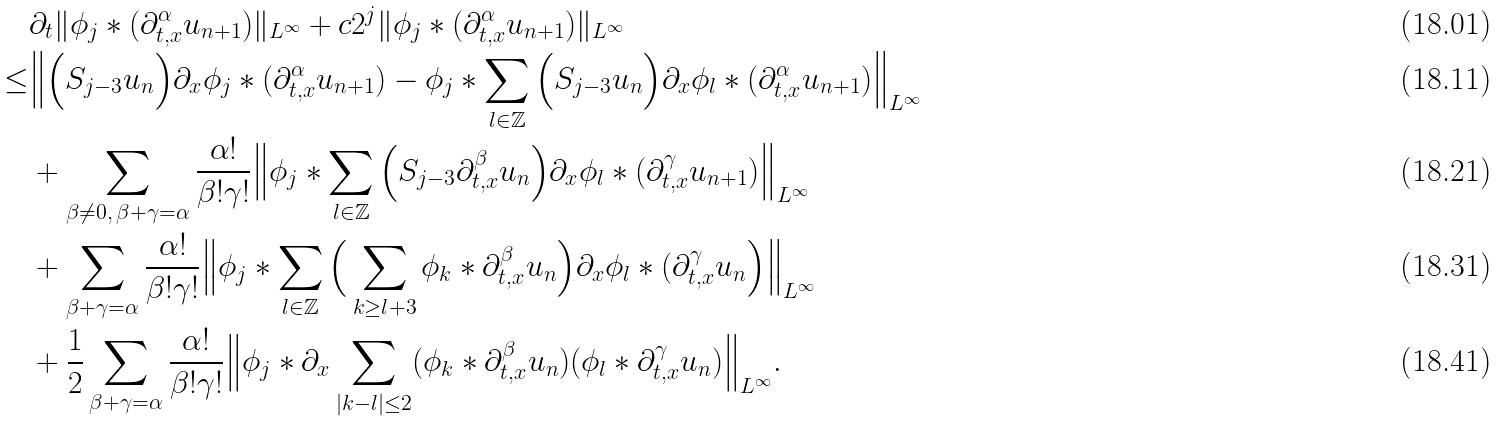<formula> <loc_0><loc_0><loc_500><loc_500>& \partial _ { t } \| \phi _ { j } * ( \partial _ { t , x } ^ { \alpha } u _ { n + 1 } ) \| _ { L ^ { \infty } } + c 2 ^ { j } \| \phi _ { j } * ( \partial _ { t , x } ^ { \alpha } u _ { n + 1 } ) \| _ { L ^ { \infty } } \\ \leq & \Big \| \Big ( S _ { j - 3 } u _ { n } \Big ) \partial _ { x } \phi _ { j } * ( \partial _ { t , x } ^ { \alpha } u _ { n + 1 } ) - \phi _ { j } * \sum _ { l \in \mathbb { Z } } \Big ( S _ { j - 3 } u _ { n } \Big ) \partial _ { x } \phi _ { l } * ( \partial _ { t , x } ^ { \alpha } u _ { n + 1 } ) \Big \| _ { L ^ { \infty } } \\ & + \sum _ { \beta \not = 0 , \, \beta + \gamma = \alpha } \frac { \alpha ! } { \beta ! \gamma ! } \Big \| \phi _ { j } * \sum _ { l \in \mathbb { Z } } \Big ( S _ { j - 3 } \partial _ { t , x } ^ { \beta } u _ { n } \Big ) \partial _ { x } \phi _ { l } * ( \partial _ { t , x } ^ { \gamma } u _ { n + 1 } ) \Big \| _ { L ^ { \infty } } \\ & + \sum _ { \beta + \gamma = \alpha } \frac { \alpha ! } { \beta ! \gamma ! } \Big \| \phi _ { j } * \sum _ { l \in \mathbb { Z } } \Big ( \sum _ { k \geq l + 3 } \phi _ { k } * \partial _ { t , x } ^ { \beta } u _ { n } \Big ) \partial _ { x } \phi _ { l } * ( \partial _ { t , x } ^ { \gamma } u _ { n } \Big ) \Big \| _ { L ^ { \infty } } \\ & + \frac { 1 } { 2 } \sum _ { \beta + \gamma = \alpha } \frac { \alpha ! } { \beta ! \gamma ! } \Big \| \phi _ { j } * \partial _ { x } \sum _ { | k - l | \leq 2 } ( \phi _ { k } * \partial _ { t , x } ^ { \beta } u _ { n } ) ( \phi _ { l } * \partial _ { t , x } ^ { \gamma } u _ { n } ) \Big \| _ { L ^ { \infty } } .</formula> 